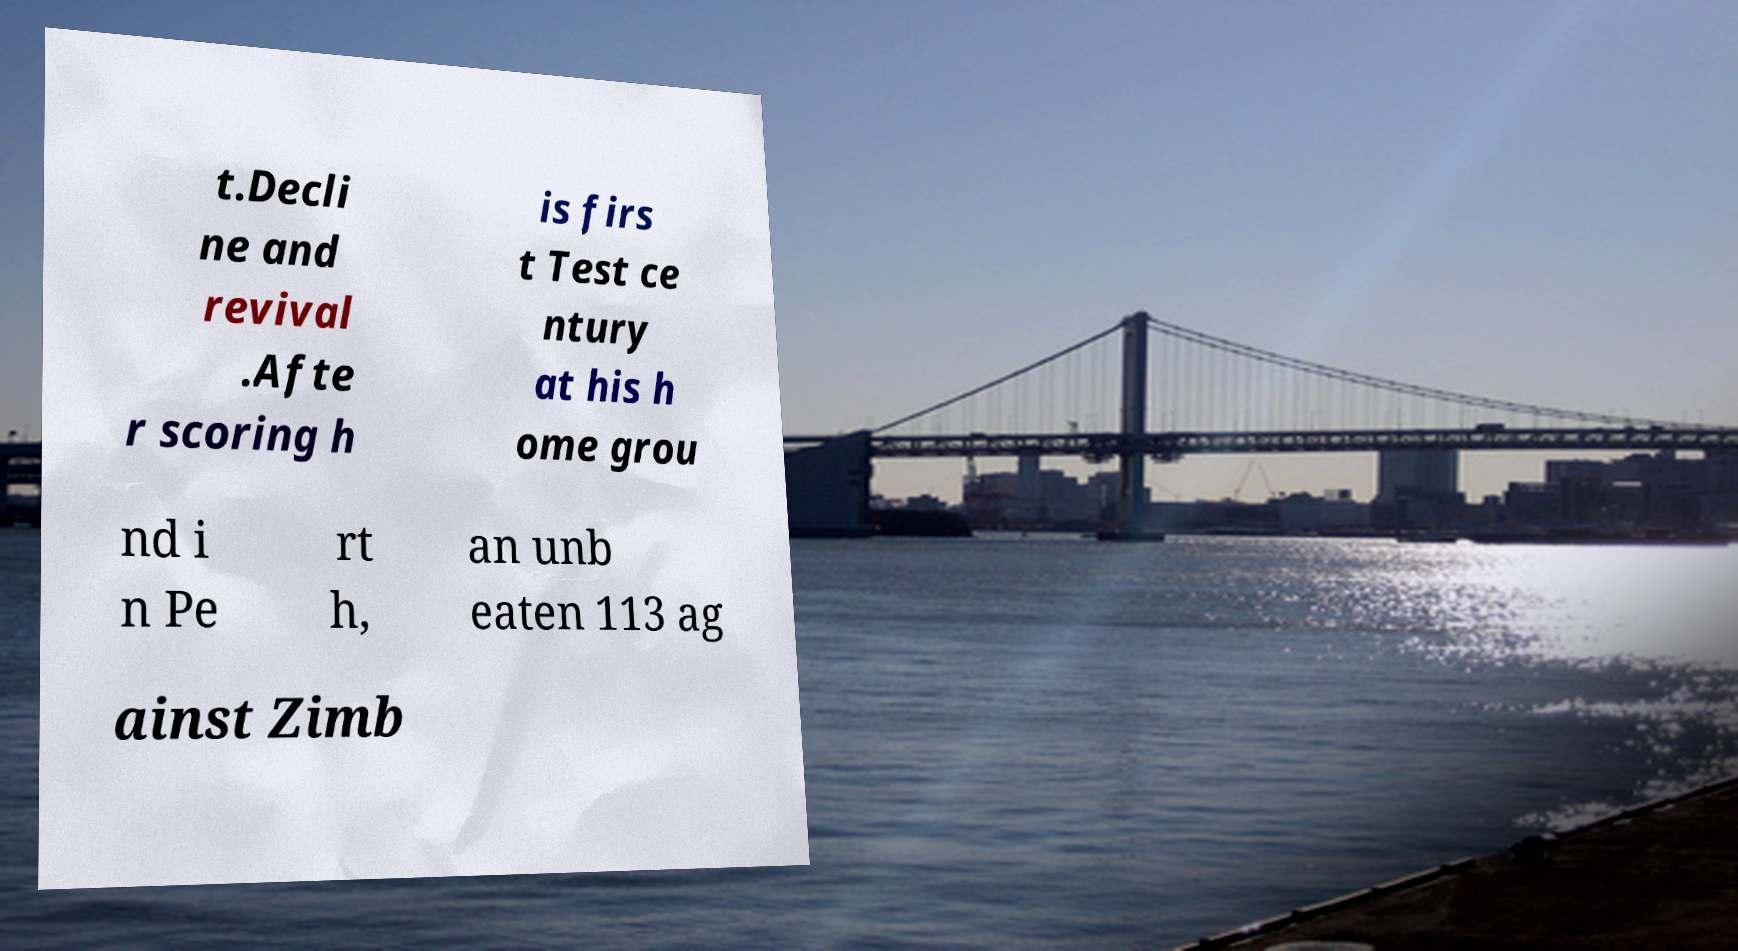I need the written content from this picture converted into text. Can you do that? t.Decli ne and revival .Afte r scoring h is firs t Test ce ntury at his h ome grou nd i n Pe rt h, an unb eaten 113 ag ainst Zimb 